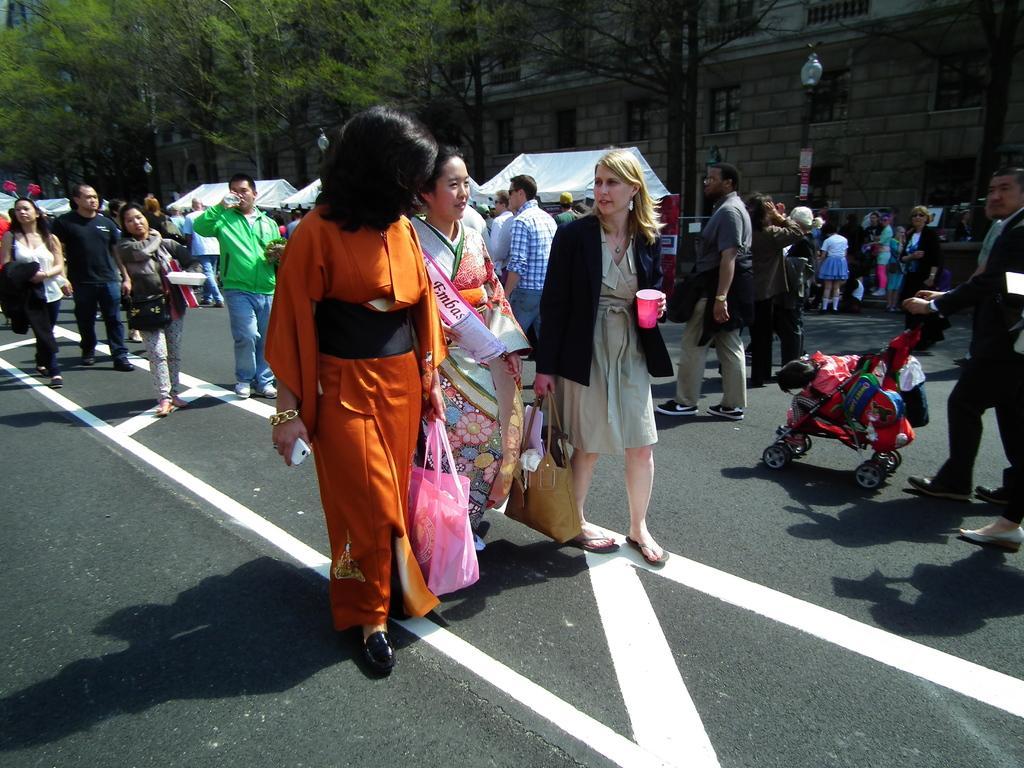Could you give a brief overview of what you see in this image? In this picture I can see there are few people walking and they are holding carry bags and there is a man holding a trolley and there is a building in the backdrop and there are trees. 